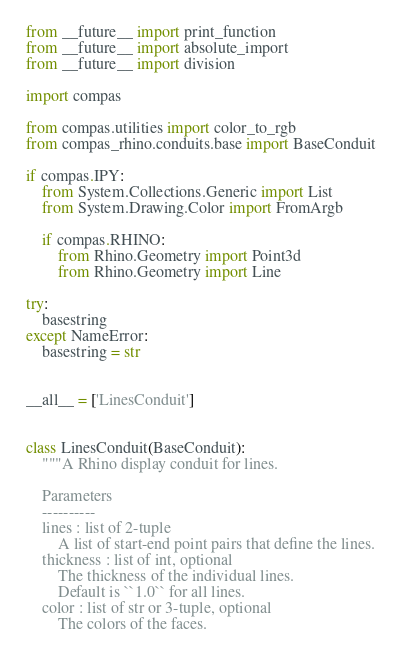Convert code to text. <code><loc_0><loc_0><loc_500><loc_500><_Python_>from __future__ import print_function
from __future__ import absolute_import
from __future__ import division

import compas

from compas.utilities import color_to_rgb
from compas_rhino.conduits.base import BaseConduit

if compas.IPY:
    from System.Collections.Generic import List
    from System.Drawing.Color import FromArgb

    if compas.RHINO:
        from Rhino.Geometry import Point3d
        from Rhino.Geometry import Line

try:
    basestring
except NameError:
    basestring = str


__all__ = ['LinesConduit']


class LinesConduit(BaseConduit):
    """A Rhino display conduit for lines.

    Parameters
    ----------
    lines : list of 2-tuple
        A list of start-end point pairs that define the lines.
    thickness : list of int, optional
        The thickness of the individual lines.
        Default is ``1.0`` for all lines.
    color : list of str or 3-tuple, optional
        The colors of the faces.</code> 